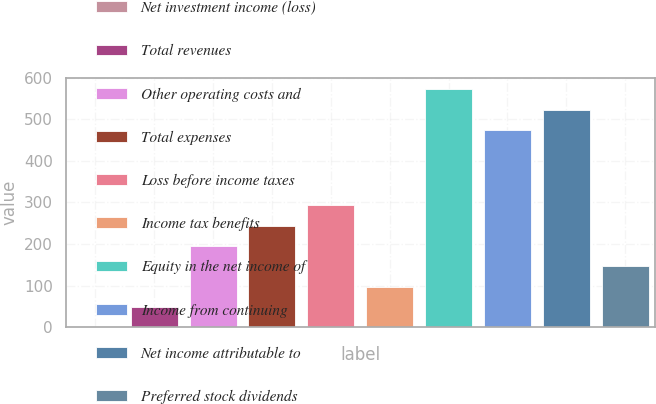Convert chart. <chart><loc_0><loc_0><loc_500><loc_500><bar_chart><fcel>Net investment income (loss)<fcel>Total revenues<fcel>Other operating costs and<fcel>Total expenses<fcel>Loss before income taxes<fcel>Income tax benefits<fcel>Equity in the net income of<fcel>Income from continuing<fcel>Net income attributable to<fcel>Preferred stock dividends<nl><fcel>0.3<fcel>49.09<fcel>195.46<fcel>244.25<fcel>293.04<fcel>97.88<fcel>571.47<fcel>473.89<fcel>522.68<fcel>146.67<nl></chart> 